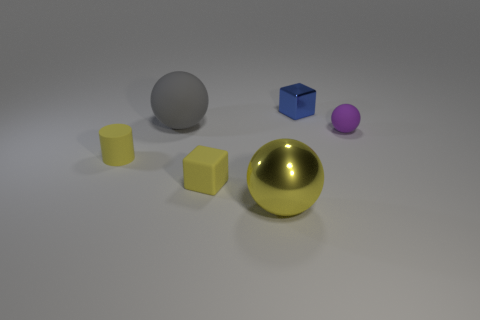Add 4 big gray blocks. How many objects exist? 10 Subtract all large balls. How many balls are left? 1 Subtract all yellow spheres. How many spheres are left? 2 Subtract all cylinders. How many objects are left? 5 Subtract 1 cylinders. How many cylinders are left? 0 Subtract all blue cylinders. Subtract all yellow spheres. How many cylinders are left? 1 Subtract all red cubes. How many yellow spheres are left? 1 Subtract all small balls. Subtract all tiny red metallic objects. How many objects are left? 5 Add 6 yellow rubber cubes. How many yellow rubber cubes are left? 7 Add 1 big yellow objects. How many big yellow objects exist? 2 